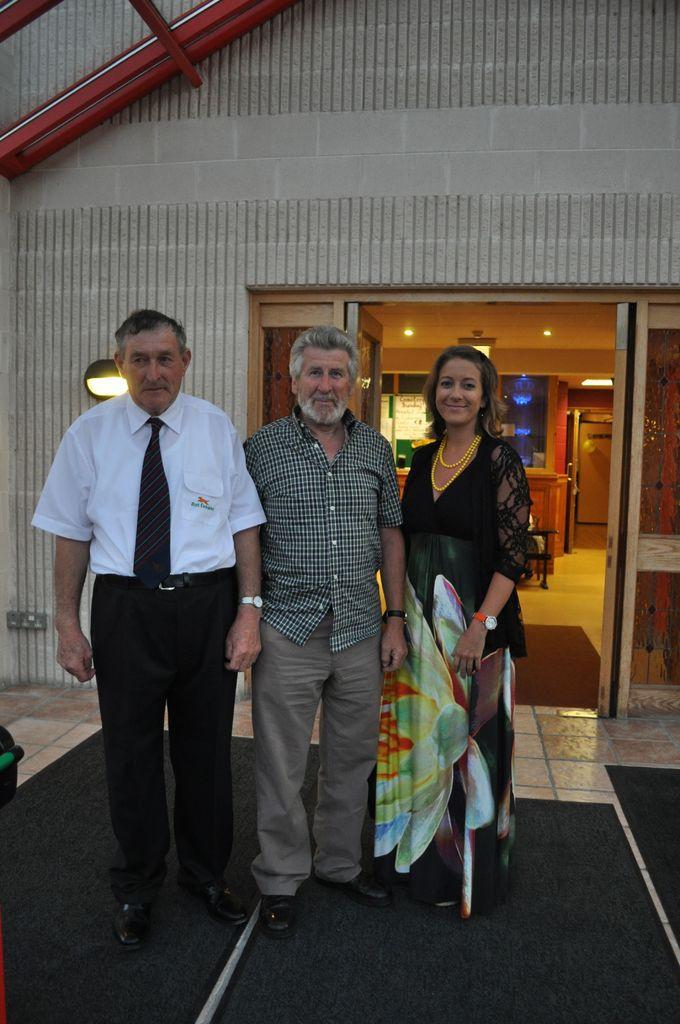Could you give a brief overview of what you see in this image? In the middle of the image three persons are standing and smiling. Behind them we can see a house. In the house we can see a table and lights. 